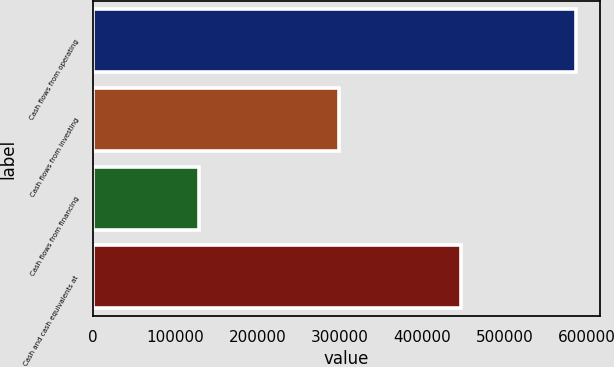Convert chart. <chart><loc_0><loc_0><loc_500><loc_500><bar_chart><fcel>Cash flows from operating<fcel>Cash flows from investing<fcel>Cash flows from financing<fcel>Cash and cash equivalents at<nl><fcel>586570<fcel>298699<fcel>128286<fcel>446656<nl></chart> 